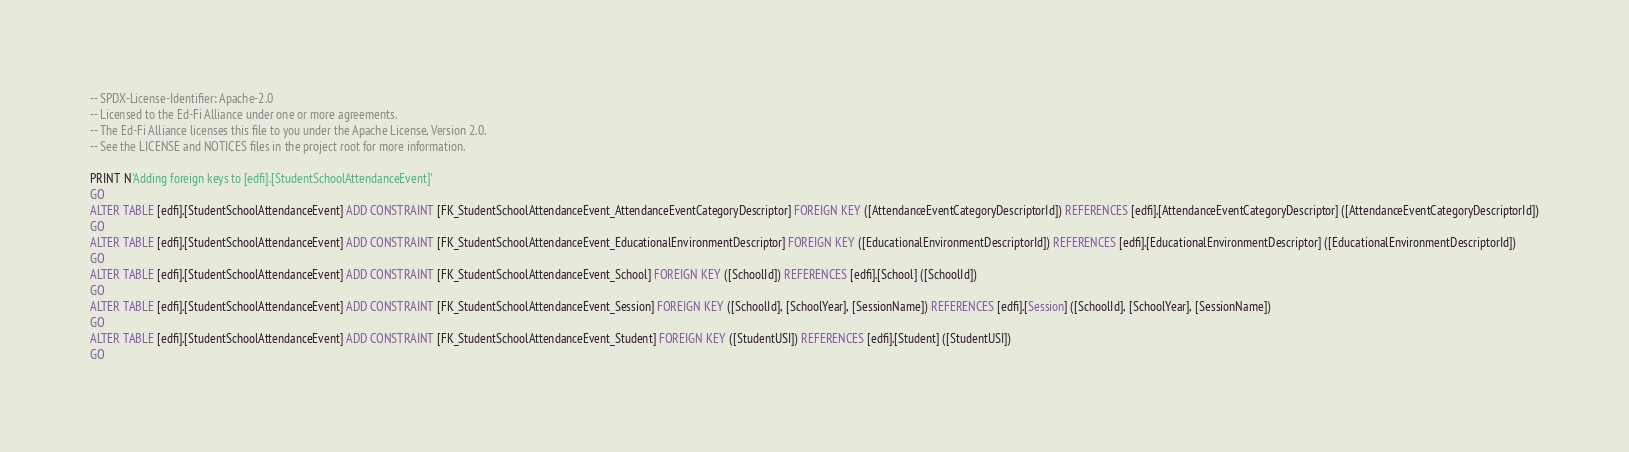<code> <loc_0><loc_0><loc_500><loc_500><_SQL_>-- SPDX-License-Identifier: Apache-2.0
-- Licensed to the Ed-Fi Alliance under one or more agreements.
-- The Ed-Fi Alliance licenses this file to you under the Apache License, Version 2.0.
-- See the LICENSE and NOTICES files in the project root for more information.

PRINT N'Adding foreign keys to [edfi].[StudentSchoolAttendanceEvent]'
GO
ALTER TABLE [edfi].[StudentSchoolAttendanceEvent] ADD CONSTRAINT [FK_StudentSchoolAttendanceEvent_AttendanceEventCategoryDescriptor] FOREIGN KEY ([AttendanceEventCategoryDescriptorId]) REFERENCES [edfi].[AttendanceEventCategoryDescriptor] ([AttendanceEventCategoryDescriptorId])
GO
ALTER TABLE [edfi].[StudentSchoolAttendanceEvent] ADD CONSTRAINT [FK_StudentSchoolAttendanceEvent_EducationalEnvironmentDescriptor] FOREIGN KEY ([EducationalEnvironmentDescriptorId]) REFERENCES [edfi].[EducationalEnvironmentDescriptor] ([EducationalEnvironmentDescriptorId])
GO
ALTER TABLE [edfi].[StudentSchoolAttendanceEvent] ADD CONSTRAINT [FK_StudentSchoolAttendanceEvent_School] FOREIGN KEY ([SchoolId]) REFERENCES [edfi].[School] ([SchoolId])
GO
ALTER TABLE [edfi].[StudentSchoolAttendanceEvent] ADD CONSTRAINT [FK_StudentSchoolAttendanceEvent_Session] FOREIGN KEY ([SchoolId], [SchoolYear], [SessionName]) REFERENCES [edfi].[Session] ([SchoolId], [SchoolYear], [SessionName])
GO
ALTER TABLE [edfi].[StudentSchoolAttendanceEvent] ADD CONSTRAINT [FK_StudentSchoolAttendanceEvent_Student] FOREIGN KEY ([StudentUSI]) REFERENCES [edfi].[Student] ([StudentUSI])
GO
</code> 